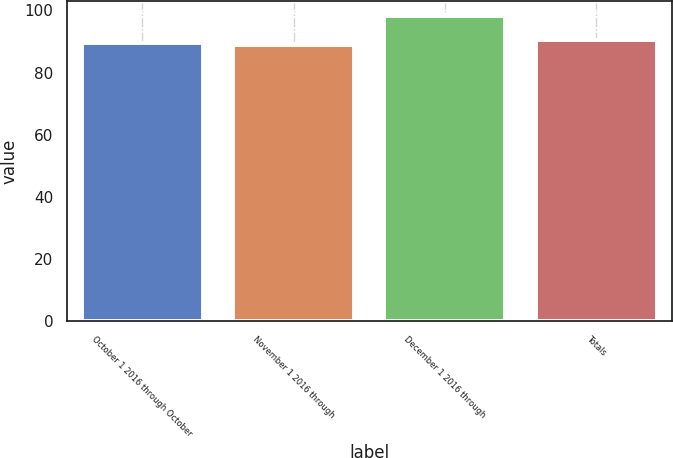<chart> <loc_0><loc_0><loc_500><loc_500><bar_chart><fcel>October 1 2016 through October<fcel>November 1 2016 through<fcel>December 1 2016 through<fcel>Totals<nl><fcel>89.67<fcel>88.73<fcel>98.08<fcel>90.61<nl></chart> 